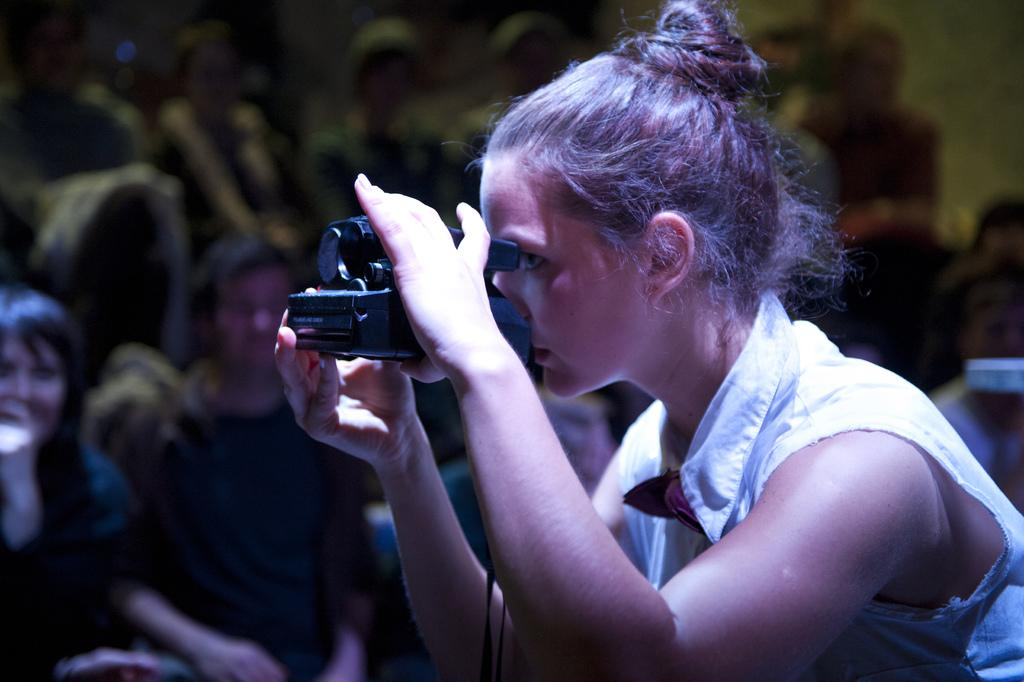Who is the main subject in the image? There is a lady in the image. What is the lady wearing? The lady is wearing a white dress. What is the lady holding in the image? The lady is holding a camera. Can you describe the background of the image? There are people in the background of the image. Is the lady swimming in a river in the image? No, the lady is not swimming in a river in the image; she is wearing a white dress and holding a camera. 